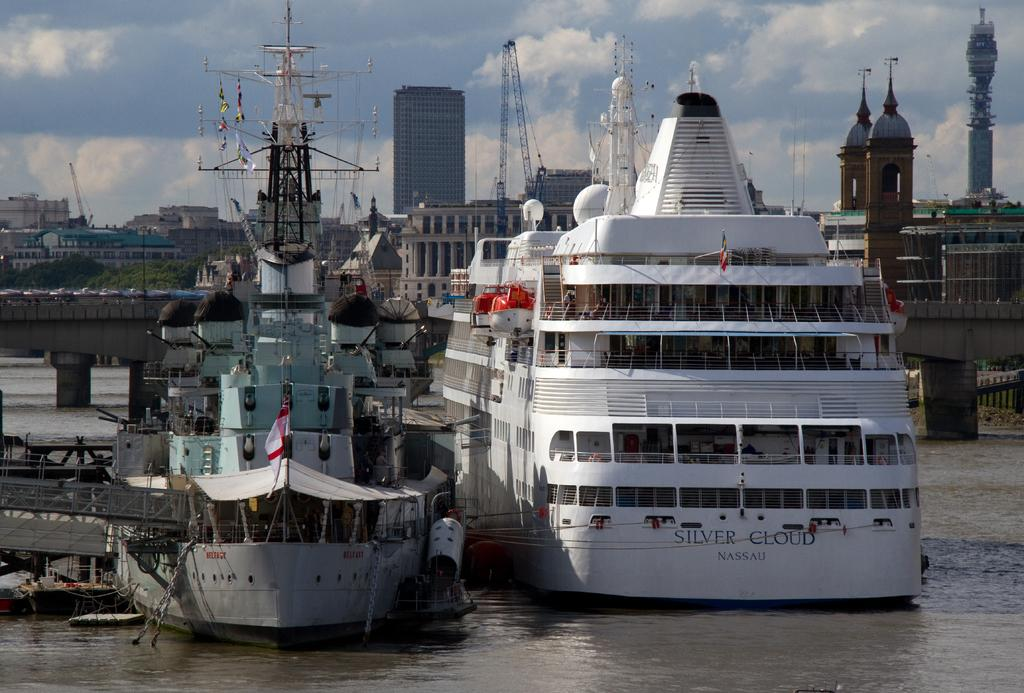<image>
Render a clear and concise summary of the photo. the ship silver cloud anchored next to a ship flying the English flag 